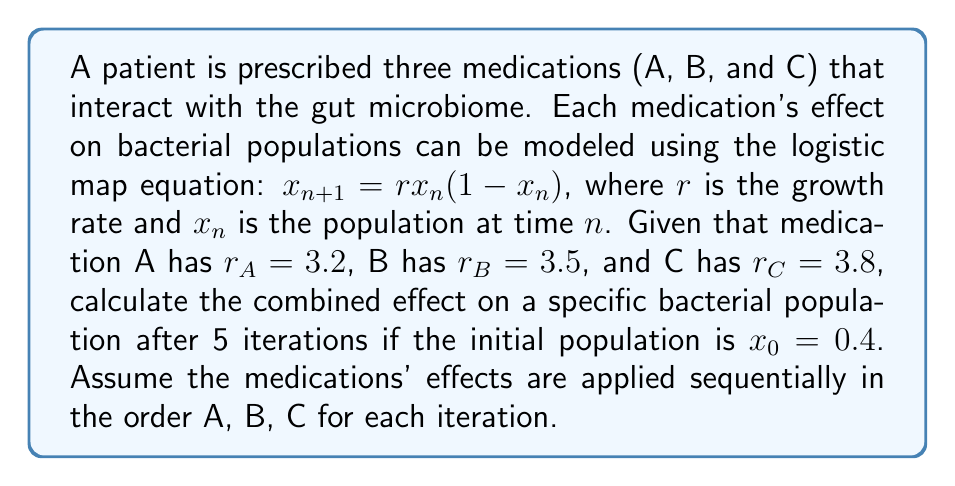Can you solve this math problem? To solve this problem, we need to apply the logistic map equation iteratively for each medication in sequence. Let's break it down step-by-step:

1) Initial population: $x_0 = 0.4$

2) For each iteration, we apply the effects of medications A, B, and C in order:

   Medication A: $x_{n+1} = 3.2x_n(1-x_n)$
   Medication B: $x_{n+1} = 3.5x_n(1-x_n)$
   Medication C: $x_{n+1} = 3.8x_n(1-x_n)$

3) Let's calculate for 5 iterations:

   Iteration 1:
   A: $x_1 = 3.2(0.4)(1-0.4) = 0.768$
   B: $x_1 = 3.5(0.768)(1-0.768) = 0.623$
   C: $x_1 = 3.8(0.623)(1-0.623) = 0.892$

   Iteration 2:
   A: $x_2 = 3.2(0.892)(1-0.892) = 0.308$
   B: $x_2 = 3.5(0.308)(1-0.308) = 0.745$
   C: $x_2 = 3.8(0.745)(1-0.745) = 0.722$

   Iteration 3:
   A: $x_3 = 3.2(0.722)(1-0.722) = 0.645$
   B: $x_3 = 3.5(0.645)(1-0.645) = 0.800$
   C: $x_3 = 3.8(0.800)(1-0.800) = 0.608$

   Iteration 4:
   A: $x_4 = 3.2(0.608)(1-0.608) = 0.766$
   B: $x_4 = 3.5(0.766)(1-0.766) = 0.628$
   C: $x_4 = 3.8(0.628)(1-0.628) = 0.889$

   Iteration 5:
   A: $x_5 = 3.2(0.889)(1-0.889) = 0.316$
   B: $x_5 = 3.5(0.316)(1-0.316) = 0.756$
   C: $x_5 = 3.8(0.756)(1-0.756) = 0.702$

4) The final population after 5 iterations is 0.702.
Answer: 0.702 